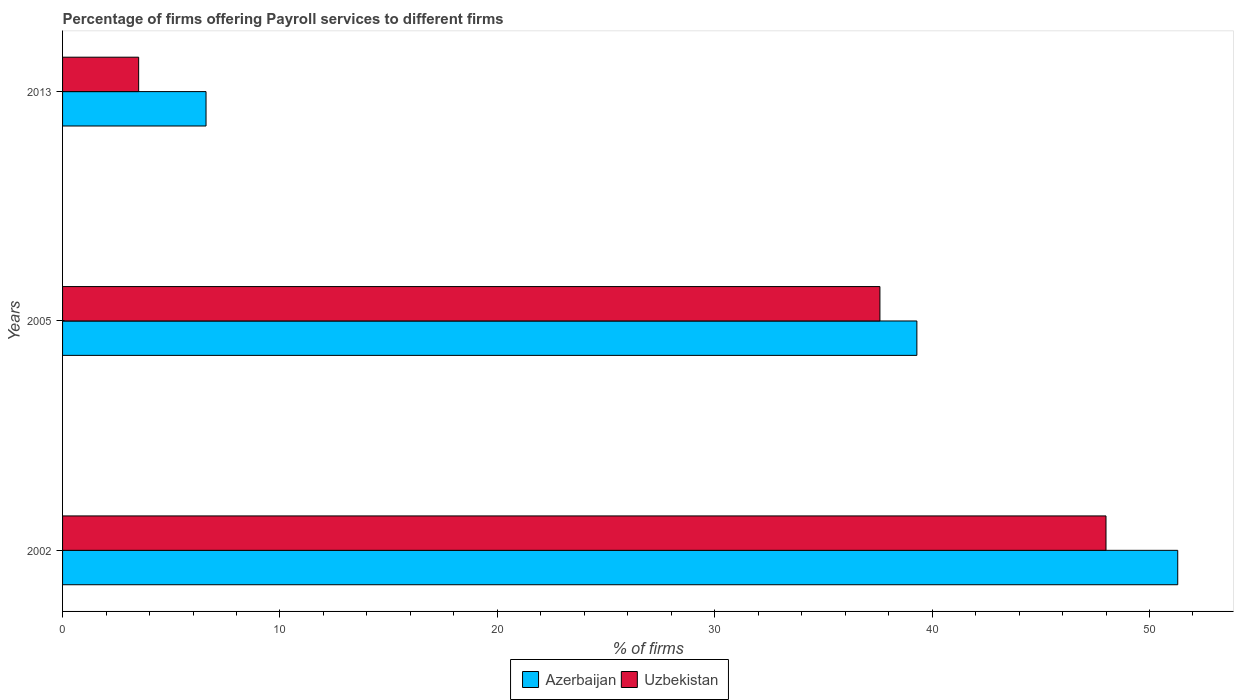How many different coloured bars are there?
Your response must be concise. 2. In how many cases, is the number of bars for a given year not equal to the number of legend labels?
Your response must be concise. 0. What is the percentage of firms offering payroll services in Uzbekistan in 2002?
Keep it short and to the point. 48. Across all years, what is the maximum percentage of firms offering payroll services in Azerbaijan?
Offer a very short reply. 51.3. In which year was the percentage of firms offering payroll services in Uzbekistan maximum?
Offer a terse response. 2002. What is the total percentage of firms offering payroll services in Uzbekistan in the graph?
Your answer should be very brief. 89.1. What is the difference between the percentage of firms offering payroll services in Uzbekistan in 2002 and that in 2005?
Keep it short and to the point. 10.4. What is the average percentage of firms offering payroll services in Uzbekistan per year?
Provide a succinct answer. 29.7. In the year 2013, what is the difference between the percentage of firms offering payroll services in Uzbekistan and percentage of firms offering payroll services in Azerbaijan?
Provide a short and direct response. -3.1. What is the ratio of the percentage of firms offering payroll services in Azerbaijan in 2002 to that in 2013?
Provide a succinct answer. 7.77. What is the difference between the highest and the second highest percentage of firms offering payroll services in Azerbaijan?
Your response must be concise. 12. What is the difference between the highest and the lowest percentage of firms offering payroll services in Azerbaijan?
Offer a very short reply. 44.7. In how many years, is the percentage of firms offering payroll services in Uzbekistan greater than the average percentage of firms offering payroll services in Uzbekistan taken over all years?
Offer a terse response. 2. Is the sum of the percentage of firms offering payroll services in Uzbekistan in 2002 and 2005 greater than the maximum percentage of firms offering payroll services in Azerbaijan across all years?
Keep it short and to the point. Yes. What does the 1st bar from the top in 2002 represents?
Your answer should be compact. Uzbekistan. What does the 2nd bar from the bottom in 2005 represents?
Make the answer very short. Uzbekistan. How many bars are there?
Ensure brevity in your answer.  6. How many years are there in the graph?
Offer a very short reply. 3. Does the graph contain any zero values?
Make the answer very short. No. Does the graph contain grids?
Provide a succinct answer. No. Where does the legend appear in the graph?
Your answer should be compact. Bottom center. How many legend labels are there?
Your answer should be very brief. 2. What is the title of the graph?
Ensure brevity in your answer.  Percentage of firms offering Payroll services to different firms. What is the label or title of the X-axis?
Make the answer very short. % of firms. What is the % of firms of Azerbaijan in 2002?
Offer a very short reply. 51.3. What is the % of firms of Uzbekistan in 2002?
Ensure brevity in your answer.  48. What is the % of firms in Azerbaijan in 2005?
Give a very brief answer. 39.3. What is the % of firms of Uzbekistan in 2005?
Ensure brevity in your answer.  37.6. Across all years, what is the maximum % of firms of Azerbaijan?
Ensure brevity in your answer.  51.3. Across all years, what is the maximum % of firms of Uzbekistan?
Your response must be concise. 48. Across all years, what is the minimum % of firms in Uzbekistan?
Give a very brief answer. 3.5. What is the total % of firms of Azerbaijan in the graph?
Your answer should be compact. 97.2. What is the total % of firms in Uzbekistan in the graph?
Keep it short and to the point. 89.1. What is the difference between the % of firms of Uzbekistan in 2002 and that in 2005?
Offer a terse response. 10.4. What is the difference between the % of firms in Azerbaijan in 2002 and that in 2013?
Your response must be concise. 44.7. What is the difference between the % of firms in Uzbekistan in 2002 and that in 2013?
Provide a succinct answer. 44.5. What is the difference between the % of firms in Azerbaijan in 2005 and that in 2013?
Keep it short and to the point. 32.7. What is the difference between the % of firms of Uzbekistan in 2005 and that in 2013?
Ensure brevity in your answer.  34.1. What is the difference between the % of firms in Azerbaijan in 2002 and the % of firms in Uzbekistan in 2013?
Provide a short and direct response. 47.8. What is the difference between the % of firms in Azerbaijan in 2005 and the % of firms in Uzbekistan in 2013?
Make the answer very short. 35.8. What is the average % of firms of Azerbaijan per year?
Your response must be concise. 32.4. What is the average % of firms in Uzbekistan per year?
Ensure brevity in your answer.  29.7. In the year 2002, what is the difference between the % of firms in Azerbaijan and % of firms in Uzbekistan?
Make the answer very short. 3.3. In the year 2005, what is the difference between the % of firms in Azerbaijan and % of firms in Uzbekistan?
Offer a terse response. 1.7. In the year 2013, what is the difference between the % of firms of Azerbaijan and % of firms of Uzbekistan?
Your answer should be very brief. 3.1. What is the ratio of the % of firms of Azerbaijan in 2002 to that in 2005?
Provide a short and direct response. 1.31. What is the ratio of the % of firms of Uzbekistan in 2002 to that in 2005?
Offer a very short reply. 1.28. What is the ratio of the % of firms of Azerbaijan in 2002 to that in 2013?
Provide a succinct answer. 7.77. What is the ratio of the % of firms of Uzbekistan in 2002 to that in 2013?
Provide a succinct answer. 13.71. What is the ratio of the % of firms of Azerbaijan in 2005 to that in 2013?
Give a very brief answer. 5.95. What is the ratio of the % of firms in Uzbekistan in 2005 to that in 2013?
Give a very brief answer. 10.74. What is the difference between the highest and the second highest % of firms in Azerbaijan?
Keep it short and to the point. 12. What is the difference between the highest and the second highest % of firms of Uzbekistan?
Your answer should be compact. 10.4. What is the difference between the highest and the lowest % of firms of Azerbaijan?
Keep it short and to the point. 44.7. What is the difference between the highest and the lowest % of firms of Uzbekistan?
Ensure brevity in your answer.  44.5. 